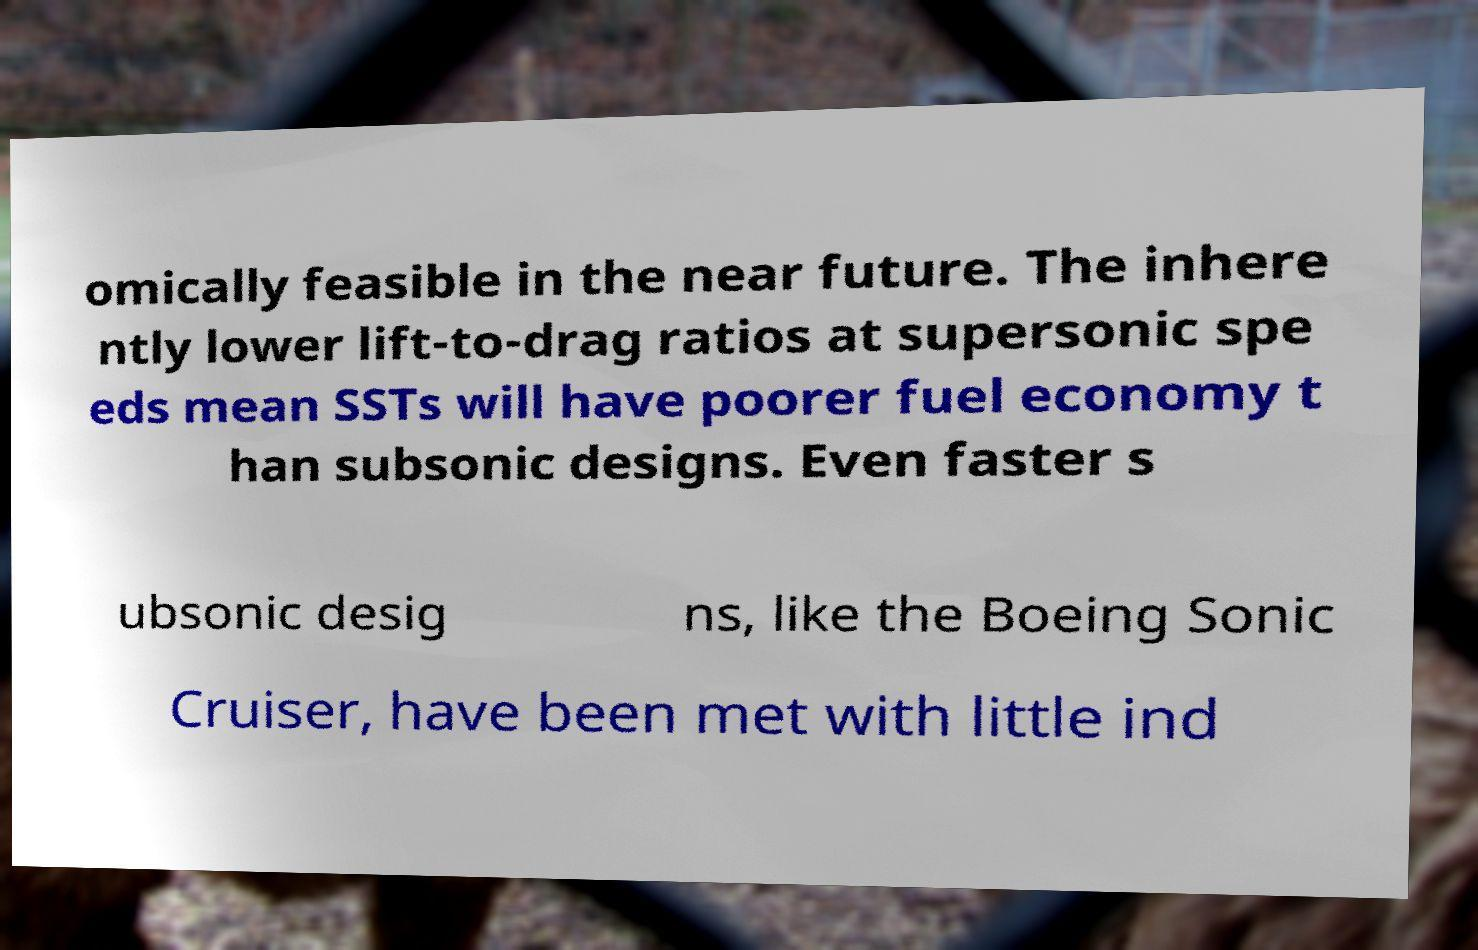Can you accurately transcribe the text from the provided image for me? omically feasible in the near future. The inhere ntly lower lift-to-drag ratios at supersonic spe eds mean SSTs will have poorer fuel economy t han subsonic designs. Even faster s ubsonic desig ns, like the Boeing Sonic Cruiser, have been met with little ind 